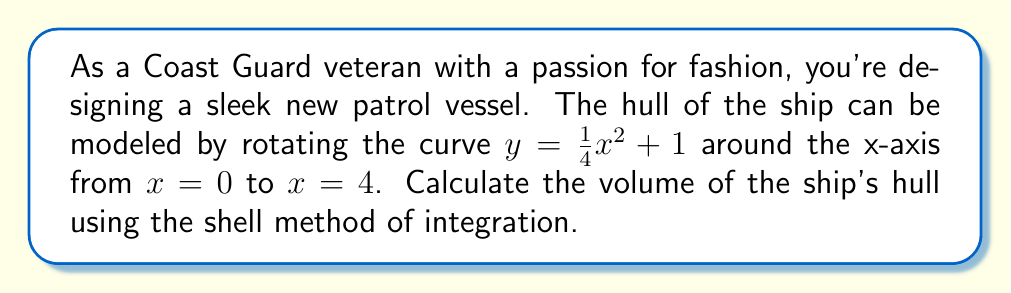Can you answer this question? To solve this problem, we'll use the shell method of integration. The steps are as follows:

1) The shell method formula for volume is:
   $$V = 2\pi \int_a^b y \cdot x \, dx$$
   where $y$ is the function and $x$ is the distance from the axis of rotation.

2) In this case, $y = \frac{1}{4}x^2 + 1$, $a = 0$, and $b = 4$.

3) Substituting into the formula:
   $$V = 2\pi \int_0^4 (\frac{1}{4}x^2 + 1) \cdot x \, dx$$

4) Distribute $x$ inside the parentheses:
   $$V = 2\pi \int_0^4 (\frac{1}{4}x^3 + x) \, dx$$

5) Integrate:
   $$V = 2\pi [\frac{1}{16}x^4 + \frac{1}{2}x^2]_0^4$$

6) Evaluate the integral:
   $$V = 2\pi [(\frac{1}{16}(4^4) + \frac{1}{2}(4^2)) - (\frac{1}{16}(0^4) + \frac{1}{2}(0^2))]$$
   $$V = 2\pi [(\frac{256}{16} + \frac{16}{2}) - 0]$$
   $$V = 2\pi [16 + 8]$$
   $$V = 2\pi [24]$$
   $$V = 48\pi$$

7) Therefore, the volume of the ship's hull is $48\pi$ cubic units.
Answer: $48\pi$ cubic units 